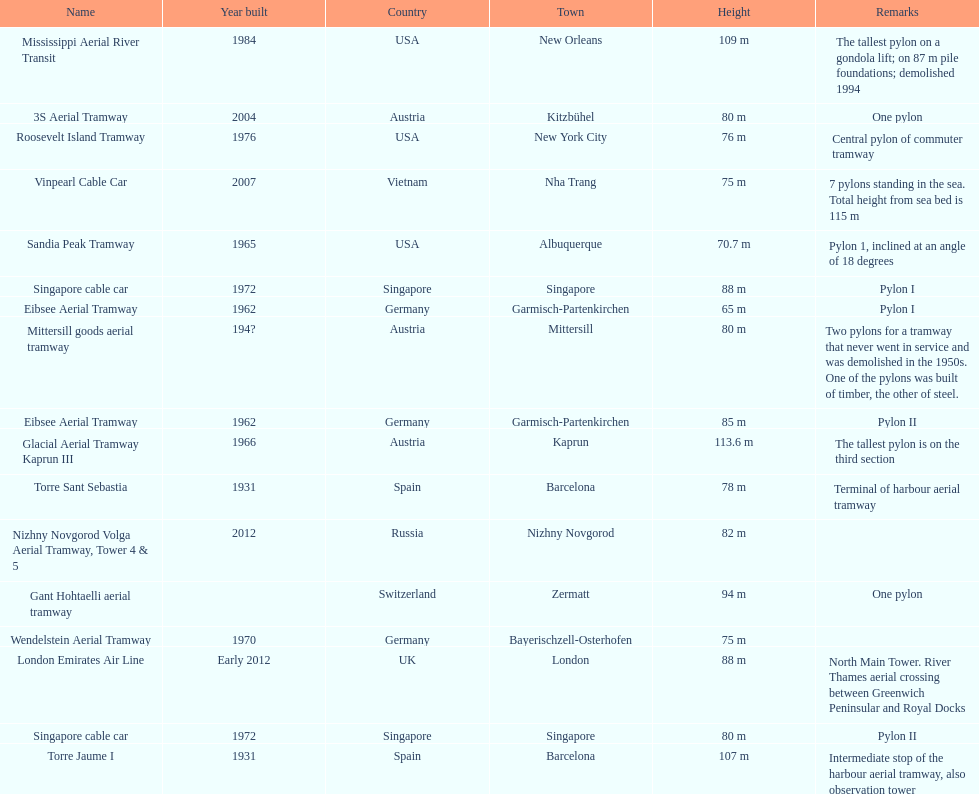The london emirates air line pylon has the same height as which pylon? Singapore cable car. 